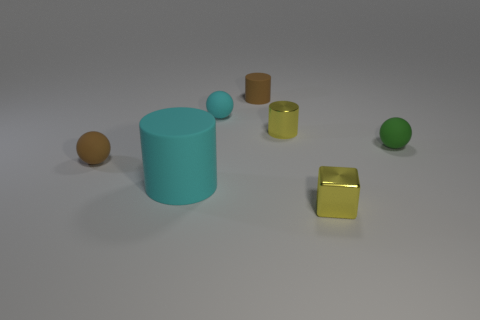Subtract all green spheres. How many spheres are left? 2 Subtract all small green rubber balls. How many balls are left? 2 Subtract 1 cyan balls. How many objects are left? 6 Subtract all cylinders. How many objects are left? 4 Subtract 2 spheres. How many spheres are left? 1 Subtract all blue cylinders. Subtract all cyan cubes. How many cylinders are left? 3 Subtract all blue cylinders. How many brown balls are left? 1 Subtract all green rubber things. Subtract all brown rubber balls. How many objects are left? 5 Add 1 tiny cyan matte balls. How many tiny cyan matte balls are left? 2 Add 2 brown rubber cubes. How many brown rubber cubes exist? 2 